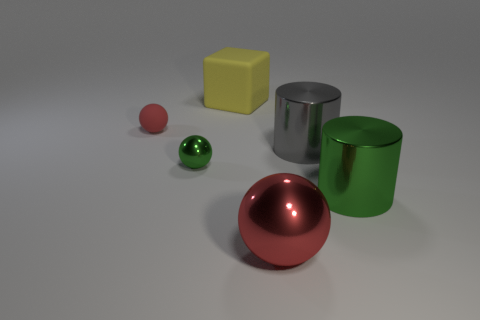Subtract all gray cylinders. How many red spheres are left? 2 Subtract all tiny spheres. How many spheres are left? 1 Add 3 big blue objects. How many objects exist? 9 Subtract all blocks. How many objects are left? 5 Add 6 red metallic objects. How many red metallic objects are left? 7 Add 3 large cyan objects. How many large cyan objects exist? 3 Subtract 0 red cylinders. How many objects are left? 6 Subtract all big rubber balls. Subtract all green metal cylinders. How many objects are left? 5 